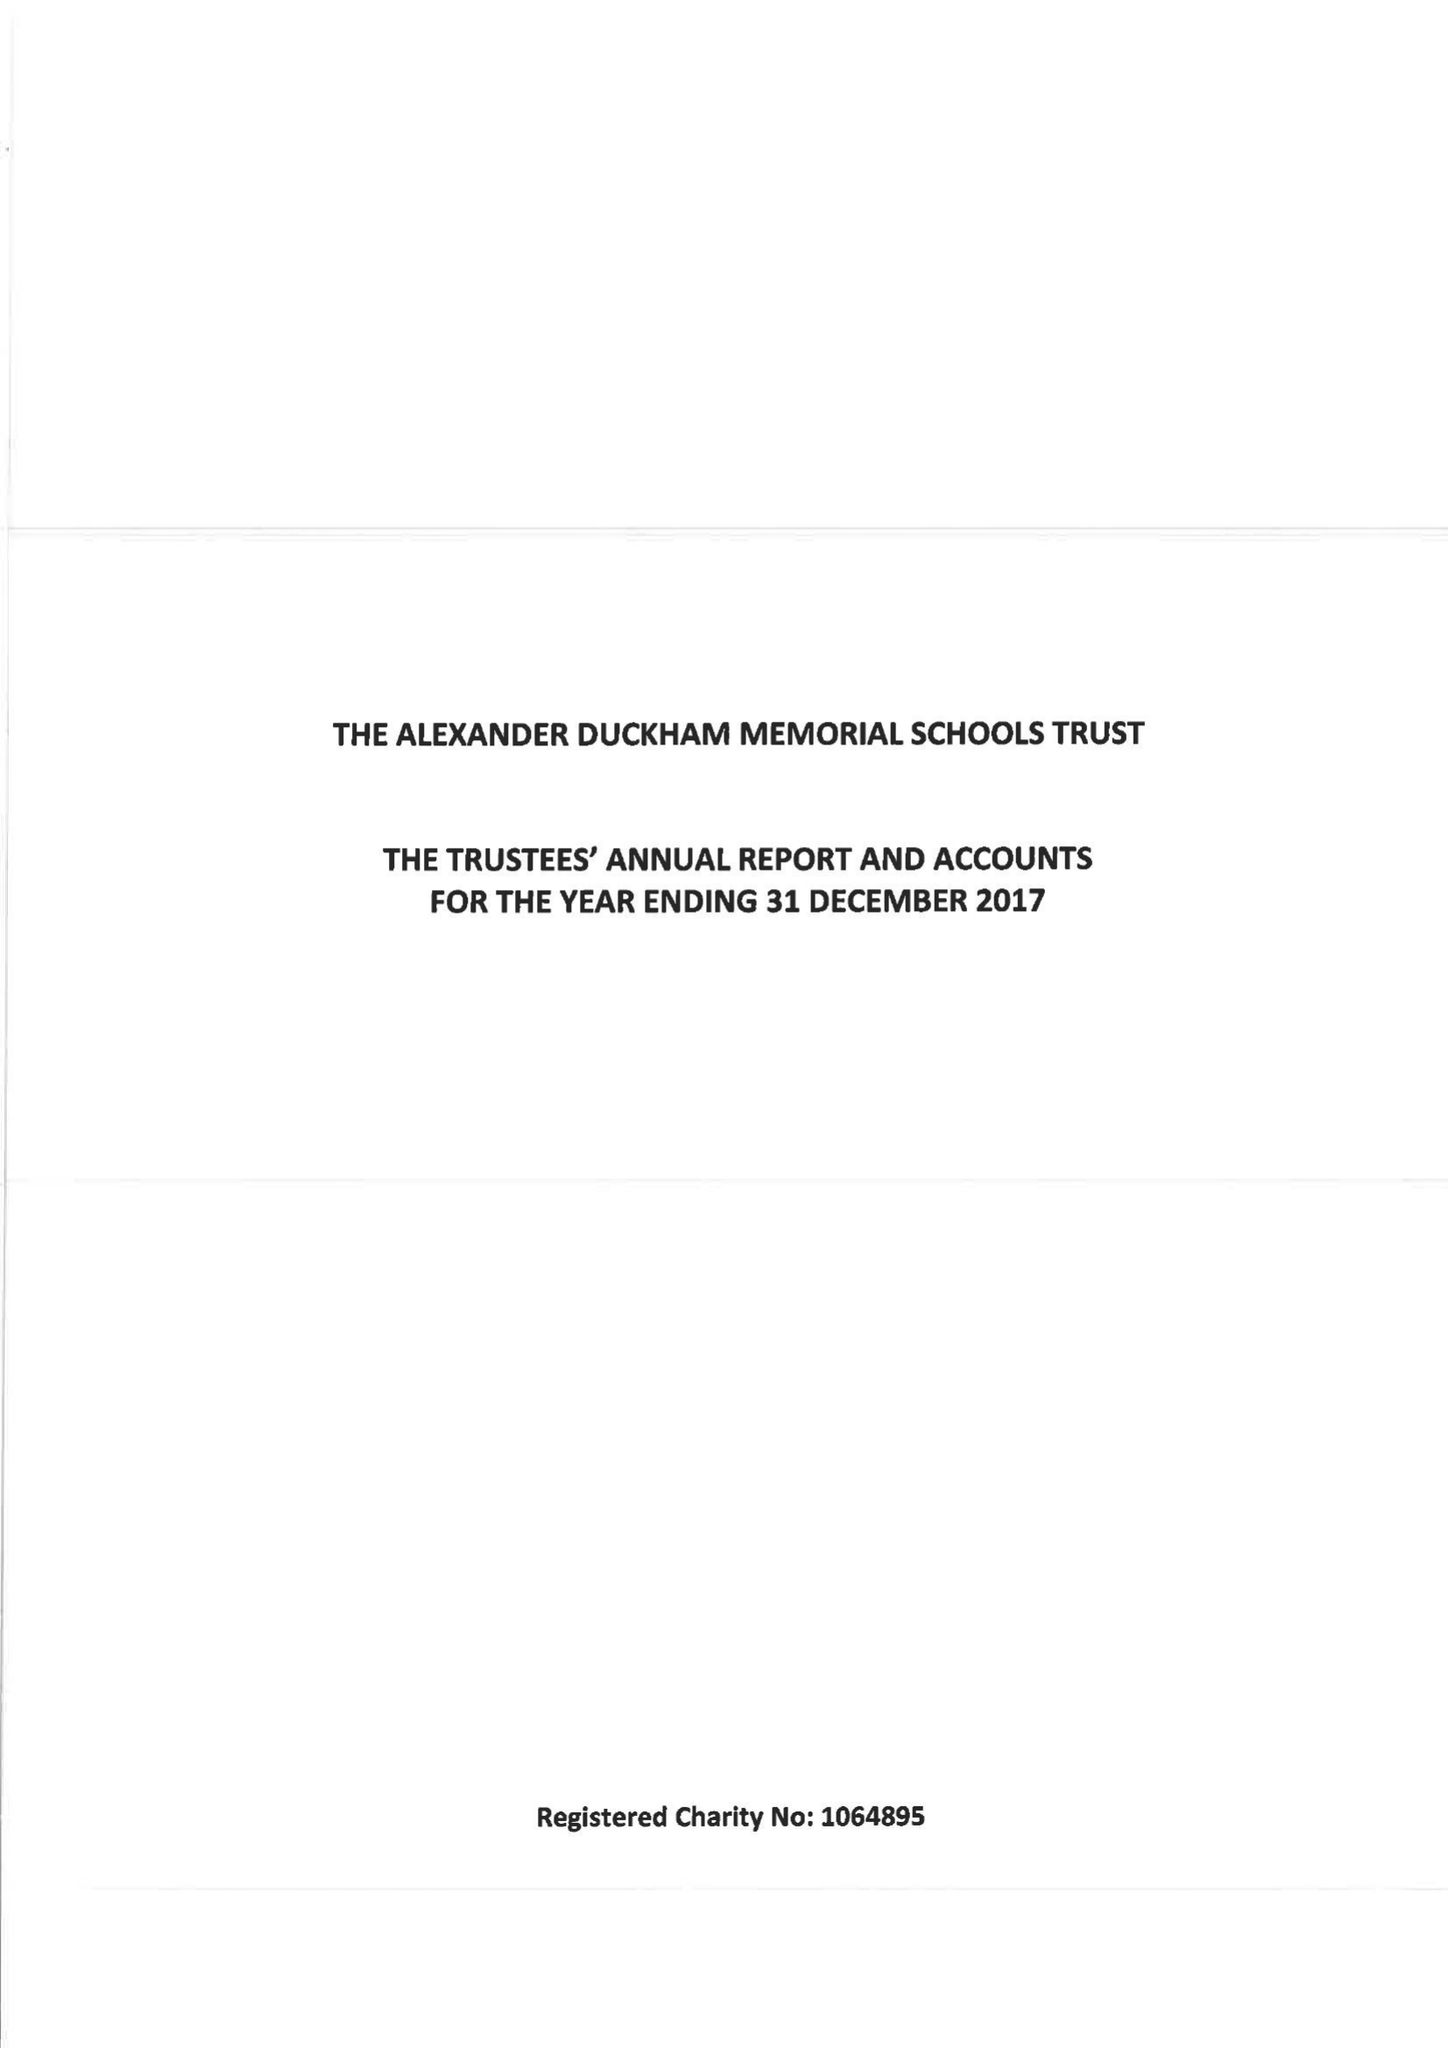What is the value for the income_annually_in_british_pounds?
Answer the question using a single word or phrase. 150516.00 